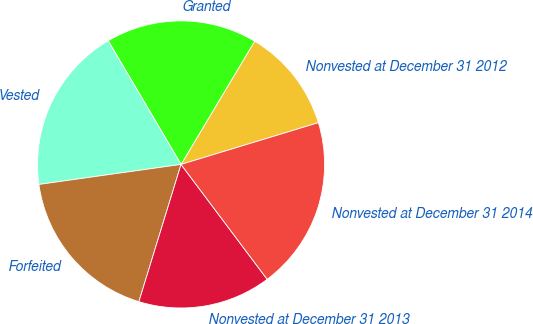Convert chart. <chart><loc_0><loc_0><loc_500><loc_500><pie_chart><fcel>Nonvested at December 31 2012<fcel>Granted<fcel>Vested<fcel>Forfeited<fcel>Nonvested at December 31 2013<fcel>Nonvested at December 31 2014<nl><fcel>11.73%<fcel>17.05%<fcel>18.75%<fcel>18.03%<fcel>14.98%<fcel>19.46%<nl></chart> 